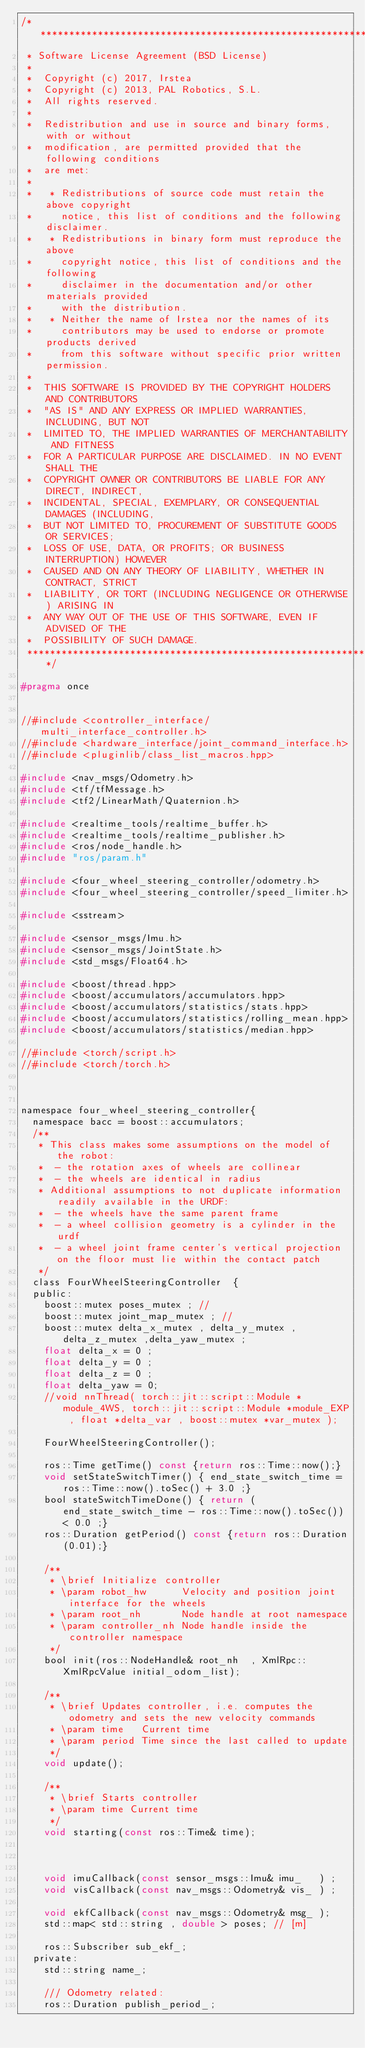Convert code to text. <code><loc_0><loc_0><loc_500><loc_500><_C_>/*********************************************************************
 * Software License Agreement (BSD License)
 *
 *  Copyright (c) 2017, Irstea
 *  Copyright (c) 2013, PAL Robotics, S.L.
 *  All rights reserved.
 *
 *  Redistribution and use in source and binary forms, with or without
 *  modification, are permitted provided that the following conditions
 *  are met:
 *
 *   * Redistributions of source code must retain the above copyright
 *     notice, this list of conditions and the following disclaimer.
 *   * Redistributions in binary form must reproduce the above
 *     copyright notice, this list of conditions and the following
 *     disclaimer in the documentation and/or other materials provided
 *     with the distribution.
 *   * Neither the name of Irstea nor the names of its
 *     contributors may be used to endorse or promote products derived
 *     from this software without specific prior written permission.
 *
 *  THIS SOFTWARE IS PROVIDED BY THE COPYRIGHT HOLDERS AND CONTRIBUTORS
 *  "AS IS" AND ANY EXPRESS OR IMPLIED WARRANTIES, INCLUDING, BUT NOT
 *  LIMITED TO, THE IMPLIED WARRANTIES OF MERCHANTABILITY AND FITNESS
 *  FOR A PARTICULAR PURPOSE ARE DISCLAIMED. IN NO EVENT SHALL THE
 *  COPYRIGHT OWNER OR CONTRIBUTORS BE LIABLE FOR ANY DIRECT, INDIRECT,
 *  INCIDENTAL, SPECIAL, EXEMPLARY, OR CONSEQUENTIAL DAMAGES (INCLUDING,
 *  BUT NOT LIMITED TO, PROCUREMENT OF SUBSTITUTE GOODS OR SERVICES;
 *  LOSS OF USE, DATA, OR PROFITS; OR BUSINESS INTERRUPTION) HOWEVER
 *  CAUSED AND ON ANY THEORY OF LIABILITY, WHETHER IN CONTRACT, STRICT
 *  LIABILITY, OR TORT (INCLUDING NEGLIGENCE OR OTHERWISE) ARISING IN
 *  ANY WAY OUT OF THE USE OF THIS SOFTWARE, EVEN IF ADVISED OF THE
 *  POSSIBILITY OF SUCH DAMAGE.
 *********************************************************************/

#pragma once


//#include <controller_interface/multi_interface_controller.h>
//#include <hardware_interface/joint_command_interface.h>
//#include <pluginlib/class_list_macros.hpp>

#include <nav_msgs/Odometry.h>
#include <tf/tfMessage.h>
#include <tf2/LinearMath/Quaternion.h>

#include <realtime_tools/realtime_buffer.h>
#include <realtime_tools/realtime_publisher.h>
#include <ros/node_handle.h>
#include "ros/param.h"

#include <four_wheel_steering_controller/odometry.h>
#include <four_wheel_steering_controller/speed_limiter.h>

#include <sstream>

#include <sensor_msgs/Imu.h>
#include <sensor_msgs/JointState.h>
#include <std_msgs/Float64.h>

#include <boost/thread.hpp>
#include <boost/accumulators/accumulators.hpp>
#include <boost/accumulators/statistics/stats.hpp>
#include <boost/accumulators/statistics/rolling_mean.hpp>
#include <boost/accumulators/statistics/median.hpp>

//#include <torch/script.h>
//#include <torch/torch.h>



namespace four_wheel_steering_controller{
  namespace bacc = boost::accumulators;
  /**
   * This class makes some assumptions on the model of the robot:
   *  - the rotation axes of wheels are collinear
   *  - the wheels are identical in radius
   * Additional assumptions to not duplicate information readily available in the URDF:
   *  - the wheels have the same parent frame
   *  - a wheel collision geometry is a cylinder in the urdf
   *  - a wheel joint frame center's vertical projection on the floor must lie within the contact patch
   */
  class FourWheelSteeringController  {
  public:
    boost::mutex poses_mutex ; // 
    boost::mutex joint_map_mutex ; // 
    boost::mutex delta_x_mutex , delta_y_mutex , delta_z_mutex ,delta_yaw_mutex ;
    float delta_x = 0 ;
    float delta_y = 0 ;
    float delta_z = 0 ;
    float delta_yaw = 0;
    //void nnThread( torch::jit::script::Module *module_4WS, torch::jit::script::Module *module_EXP , float *delta_var , boost::mutex *var_mutex );

    FourWheelSteeringController();

    ros::Time getTime() const {return ros::Time::now();}
    void setStateSwitchTimer() { end_state_switch_time = ros::Time::now().toSec() + 3.0 ;}
    bool stateSwitchTimeDone() { return (end_state_switch_time - ros::Time::now().toSec()) < 0.0 ;}
    ros::Duration getPeriod() const {return ros::Duration(0.01);}

    /**
     * \brief Initialize controller
     * \param robot_hw      Velocity and position joint interface for the wheels
     * \param root_nh       Node handle at root namespace
     * \param controller_nh Node handle inside the controller namespace
     */
    bool init(ros::NodeHandle& root_nh  , XmlRpc::XmlRpcValue initial_odom_list);

    /**
     * \brief Updates controller, i.e. computes the odometry and sets the new velocity commands
     * \param time   Current time
     * \param period Time since the last called to update
     */
    void update();

    /**
     * \brief Starts controller
     * \param time Current time
     */
    void starting(const ros::Time& time);



    void imuCallback(const sensor_msgs::Imu& imu_   ) ;
    void visCallback(const nav_msgs::Odometry& vis_ ) ;

    void ekfCallback(const nav_msgs::Odometry& msg_ );
    std::map< std::string , double > poses; // [m]

    ros::Subscriber sub_ekf_;
  private:
    std::string name_;

    /// Odometry related:
    ros::Duration publish_period_;</code> 